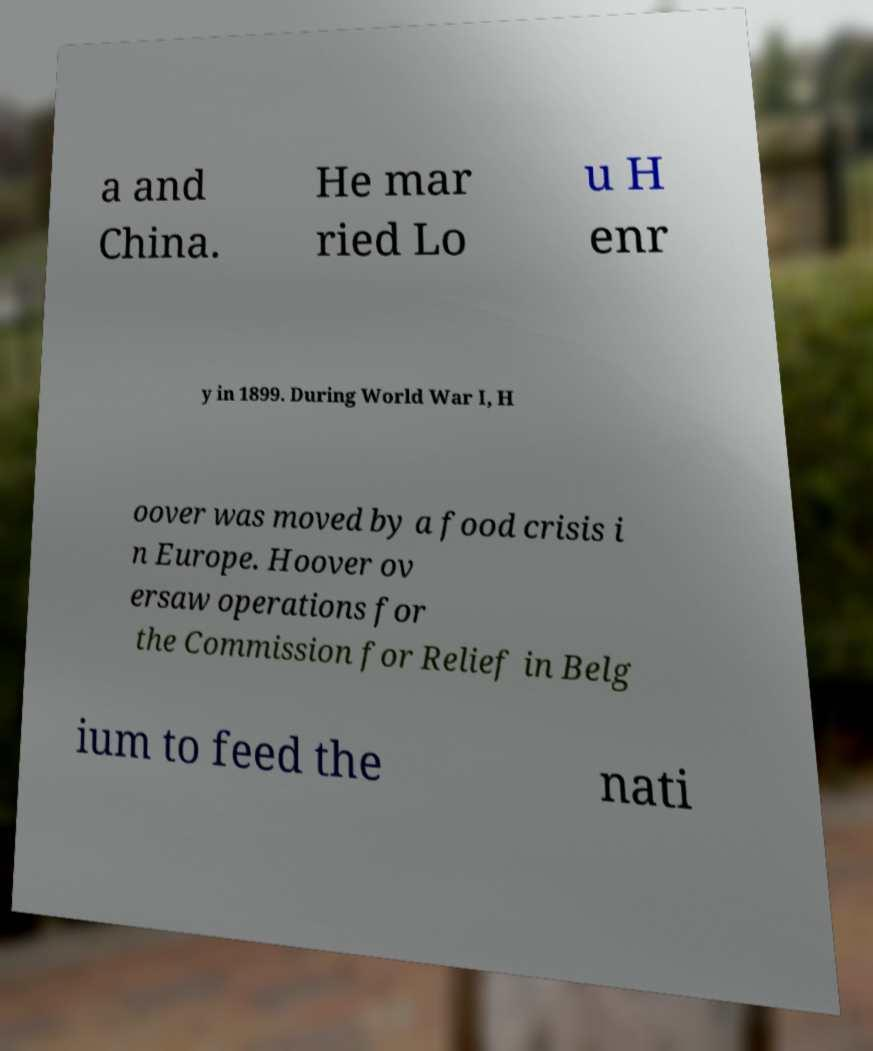Could you assist in decoding the text presented in this image and type it out clearly? a and China. He mar ried Lo u H enr y in 1899. During World War I, H oover was moved by a food crisis i n Europe. Hoover ov ersaw operations for the Commission for Relief in Belg ium to feed the nati 